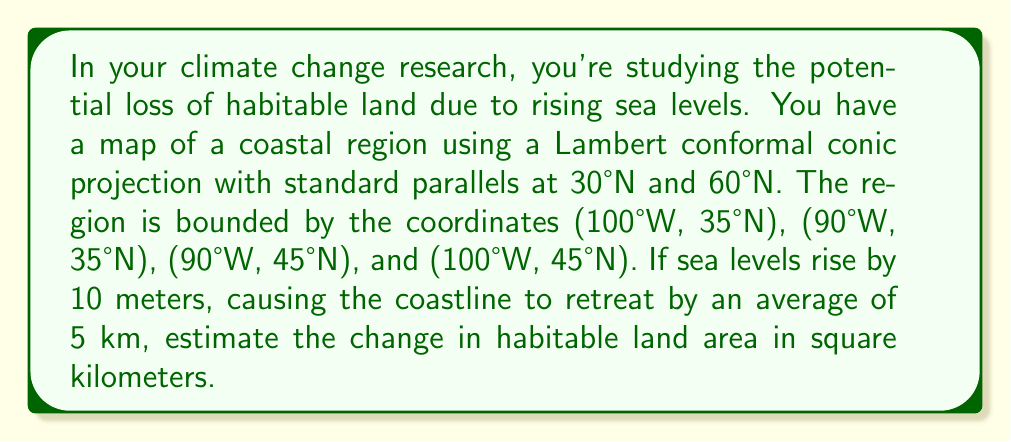Give your solution to this math problem. To solve this problem, we need to follow these steps:

1) First, we need to calculate the area of the region in the projected coordinate system. The Lambert conformal conic projection preserves shape but not area, so we need to account for this.

2) The scale factor for area in a Lambert conformal conic projection is given by:

   $$k^2 = \frac{\sin \phi_1 \sin \phi_2}{(n \sin \phi)^2} (\frac{\tan(\frac{\pi}{4} + \frac{\phi}{2})}{\tan(\frac{\pi}{4} + \frac{\phi_1}{2})})^{2n}$$

   where $\phi_1$ and $\phi_2$ are the standard parallels, $\phi$ is the latitude, and $n = \frac{\ln(\cos \phi_1 / \cos \phi_2)}{\ln(\tan(\frac{\pi}{4} + \frac{\phi_2}{2}) / \tan(\frac{\pi}{4} + \frac{\phi_1}{2}))}$

3) We'll use the average latitude of 40°N for our calculation. Converting to radians:
   $\phi_1 = 30° = \frac{\pi}{6}$, $\phi_2 = 60° = \frac{\pi}{3}$, $\phi = 40° = \frac{2\pi}{9}$

4) Calculating $n$:
   $$n = \frac{\ln(\cos(\frac{\pi}{6}) / \cos(\frac{\pi}{3}))}{\ln(\tan(\frac{\pi}{4} + \frac{\pi}{6}) / \tan(\frac{\pi}{4} + \frac{\pi}{12}))} \approx 0.7256$$

5) Now we can calculate $k^2$:
   $$k^2 \approx 0.9724$$

6) The area of the region in geographic coordinates is:
   $$(100°W - 90°W) * (45°N - 35°N) = 10° * 10° \approx 1,235,500 \text{ km}^2$$

7) Adjusting for the projection:
   $$1,235,500 * 0.9724 \approx 1,201,400 \text{ km}^2$$

8) The coastline retreats by 5 km on average. Assuming this affects two sides of our square region:
   $$\text{Lost area} = 2 * 5 \text{ km} * 1110 \text{ km} = 11,100 \text{ km}^2$$

9) The change in habitable land area is therefore approximately 11,100 km².
Answer: The estimated change (loss) in habitable land area is approximately 11,100 km². 